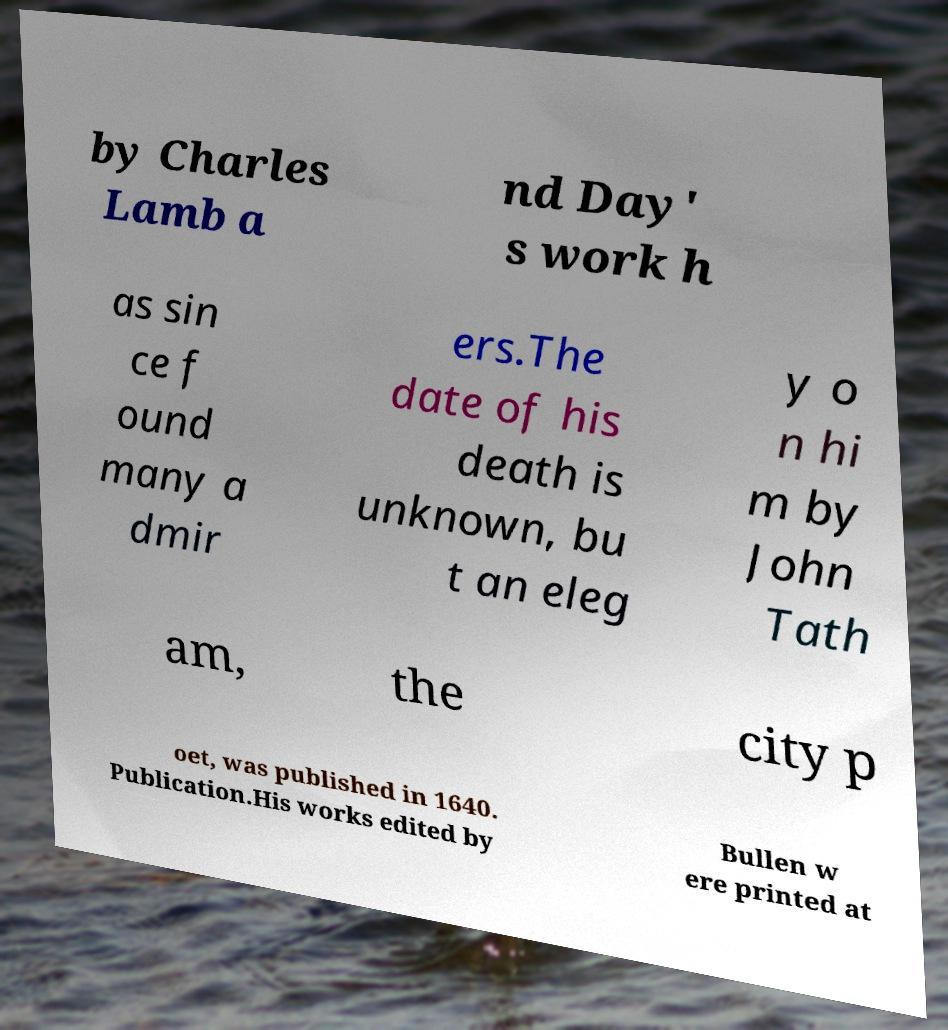For documentation purposes, I need the text within this image transcribed. Could you provide that? by Charles Lamb a nd Day' s work h as sin ce f ound many a dmir ers.The date of his death is unknown, bu t an eleg y o n hi m by John Tath am, the city p oet, was published in 1640. Publication.His works edited by Bullen w ere printed at 